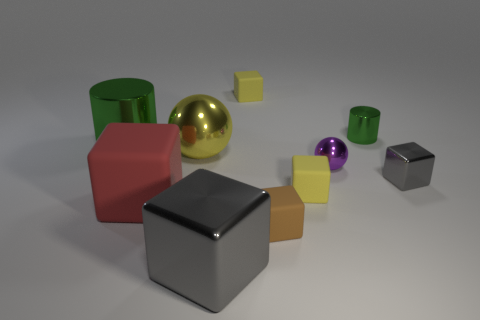Subtract all brown blocks. How many blocks are left? 5 Subtract all tiny yellow cubes. How many cubes are left? 4 Subtract all blue blocks. Subtract all brown spheres. How many blocks are left? 6 Subtract all cylinders. How many objects are left? 8 Add 3 big rubber cubes. How many big rubber cubes are left? 4 Add 8 yellow matte blocks. How many yellow matte blocks exist? 10 Subtract 0 red cylinders. How many objects are left? 10 Subtract all gray shiny cubes. Subtract all large yellow objects. How many objects are left? 7 